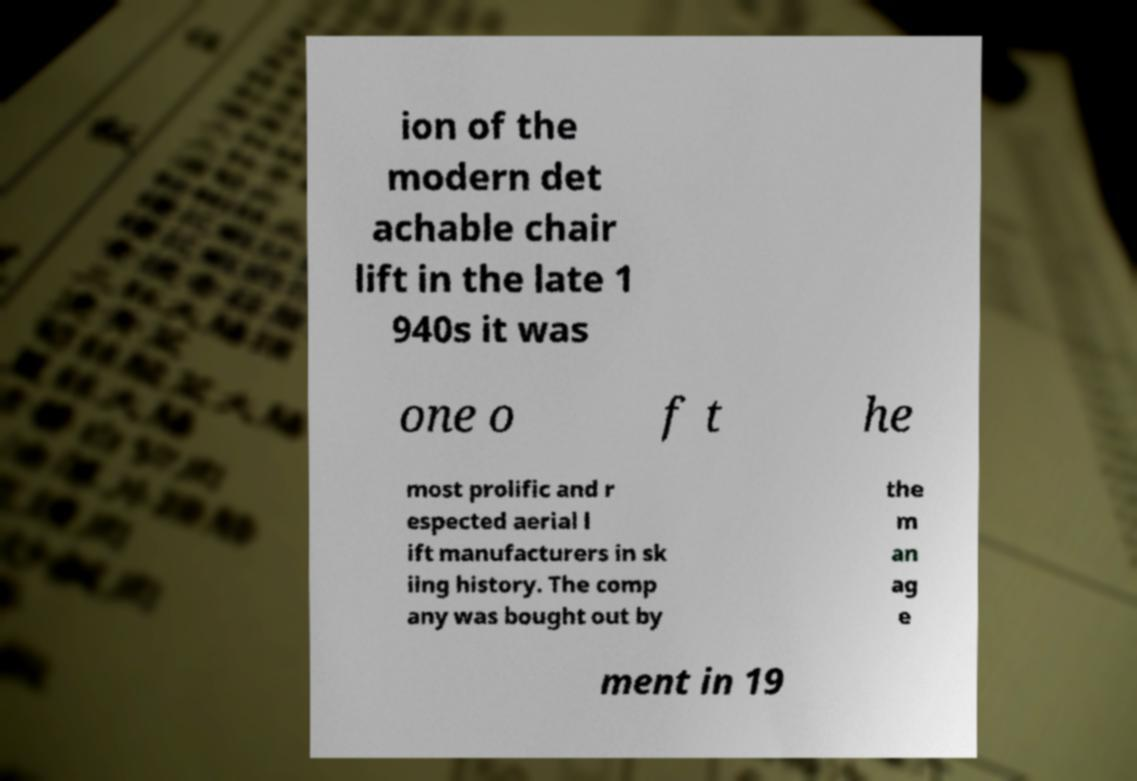Could you assist in decoding the text presented in this image and type it out clearly? ion of the modern det achable chair lift in the late 1 940s it was one o f t he most prolific and r espected aerial l ift manufacturers in sk iing history. The comp any was bought out by the m an ag e ment in 19 